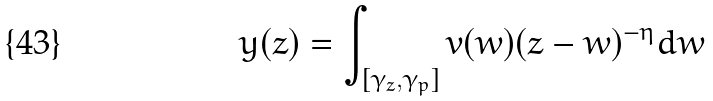<formula> <loc_0><loc_0><loc_500><loc_500>& y ( z ) = \int _ { [ \gamma _ { z } , \gamma _ { p } ] } v ( w ) ( z - w ) ^ { - \eta } d w</formula> 